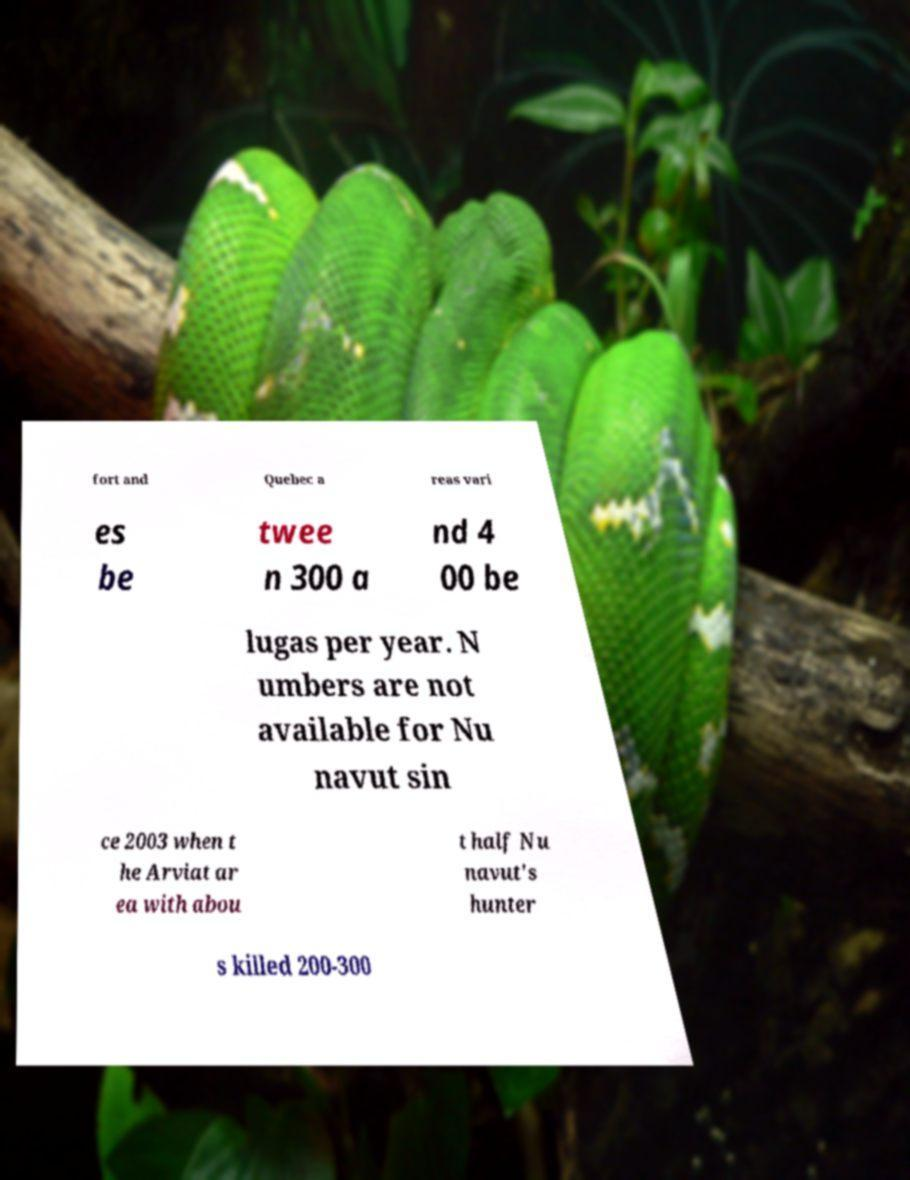Can you read and provide the text displayed in the image?This photo seems to have some interesting text. Can you extract and type it out for me? fort and Quebec a reas vari es be twee n 300 a nd 4 00 be lugas per year. N umbers are not available for Nu navut sin ce 2003 when t he Arviat ar ea with abou t half Nu navut's hunter s killed 200-300 